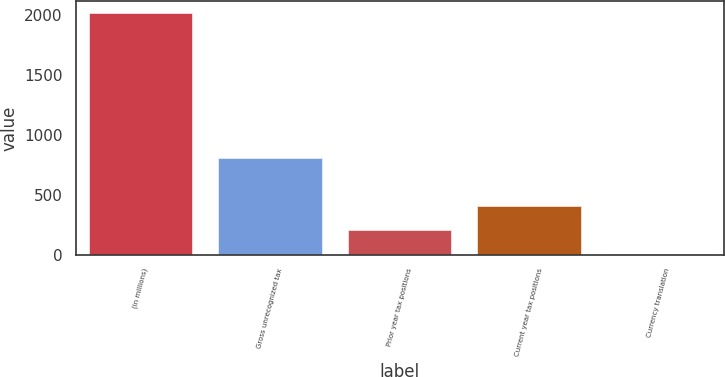<chart> <loc_0><loc_0><loc_500><loc_500><bar_chart><fcel>(in millions)<fcel>Gross unrecognized tax<fcel>Prior year tax positions<fcel>Current year tax positions<fcel>Currency translation<nl><fcel>2012<fcel>805.88<fcel>202.82<fcel>403.84<fcel>1.8<nl></chart> 